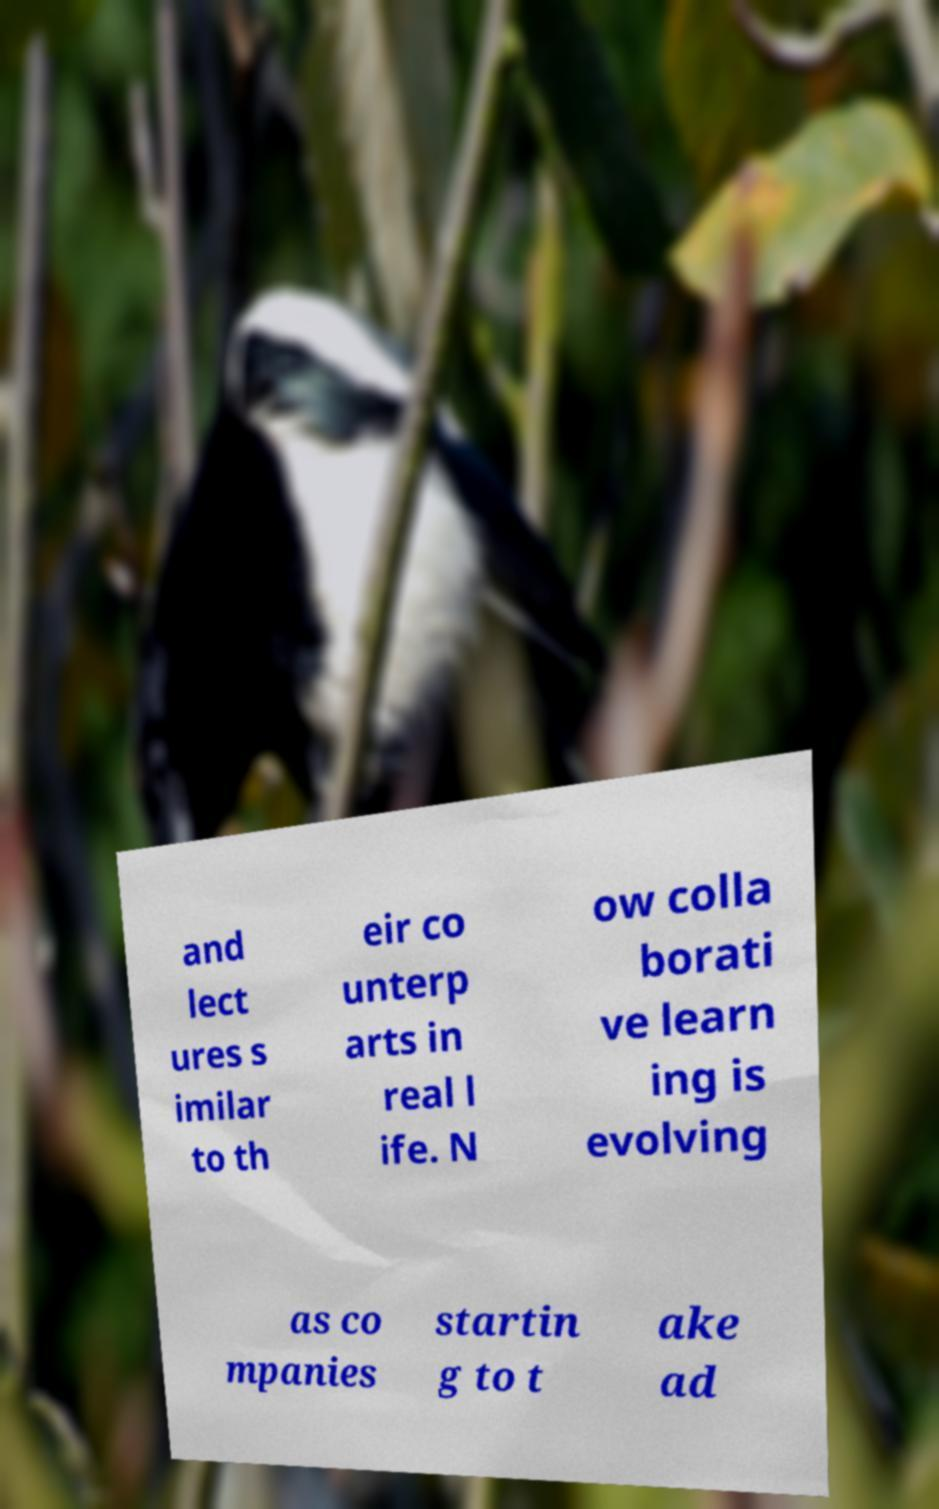Can you accurately transcribe the text from the provided image for me? and lect ures s imilar to th eir co unterp arts in real l ife. N ow colla borati ve learn ing is evolving as co mpanies startin g to t ake ad 